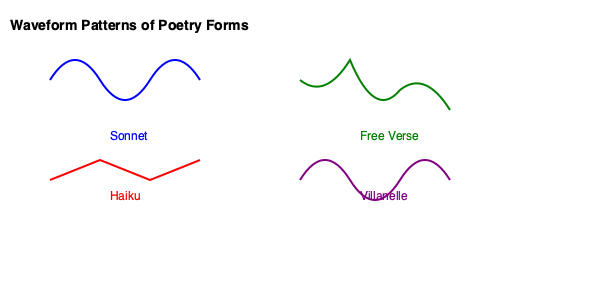Analyze the waveform patterns representing different poetry forms in the image above. Which form exhibits the most regular and consistent rhythm, and how does this relate to its structural characteristics? To answer this question, we need to examine each waveform pattern and relate it to the structural characteristics of the corresponding poetry form:

1. Sonnet (blue): Shows a regular, repeating pattern with consistent peaks and troughs. This reflects the sonnet's structured nature, typically consisting of 14 lines with a regular meter (often iambic pentameter).

2. Haiku (red): Displays a simple, linear pattern with three distinct segments. This corresponds to the haiku's three-line structure with a 5-7-5 syllable count.

3. Free Verse (green): Exhibits an irregular, unpredictable pattern. This mirrors the flexibility and lack of formal metrical structure in free verse poetry.

4. Villanelle (purple): Shows a repeating pattern similar to the sonnet, but with more pronounced repetitions. This reflects the villanelle's highly structured form with repeating lines and a specific rhyme scheme.

Among these, the Sonnet (blue) waveform demonstrates the most regular and consistent rhythm. Its evenly spaced peaks and troughs represent the consistent meter (typically iambic pentameter) found in sonnets. This regularity relates directly to the sonnet's structural characteristics:

- Fixed length of 14 lines
- Consistent meter throughout (usually iambic pentameter)
- Regular rhyme scheme (e.g., ABAB CDCD EFEF GG for English sonnets)

The sonnet's strict adherence to these formal elements results in a highly regular rhythmic pattern, which is clearly represented in the waveform.
Answer: Sonnet, due to its consistent meter and structure. 